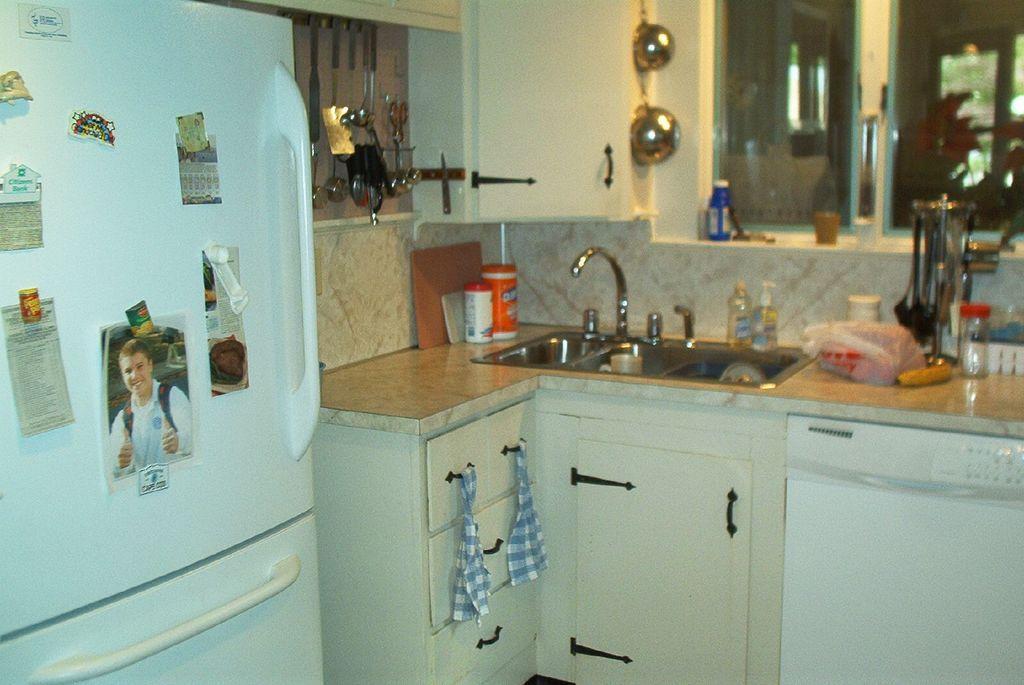Please provide a concise description of this image. It looks like a kitchen room on the left side, it's a refrigerator in white color, in the middle there is a tap,sink and utensils. 